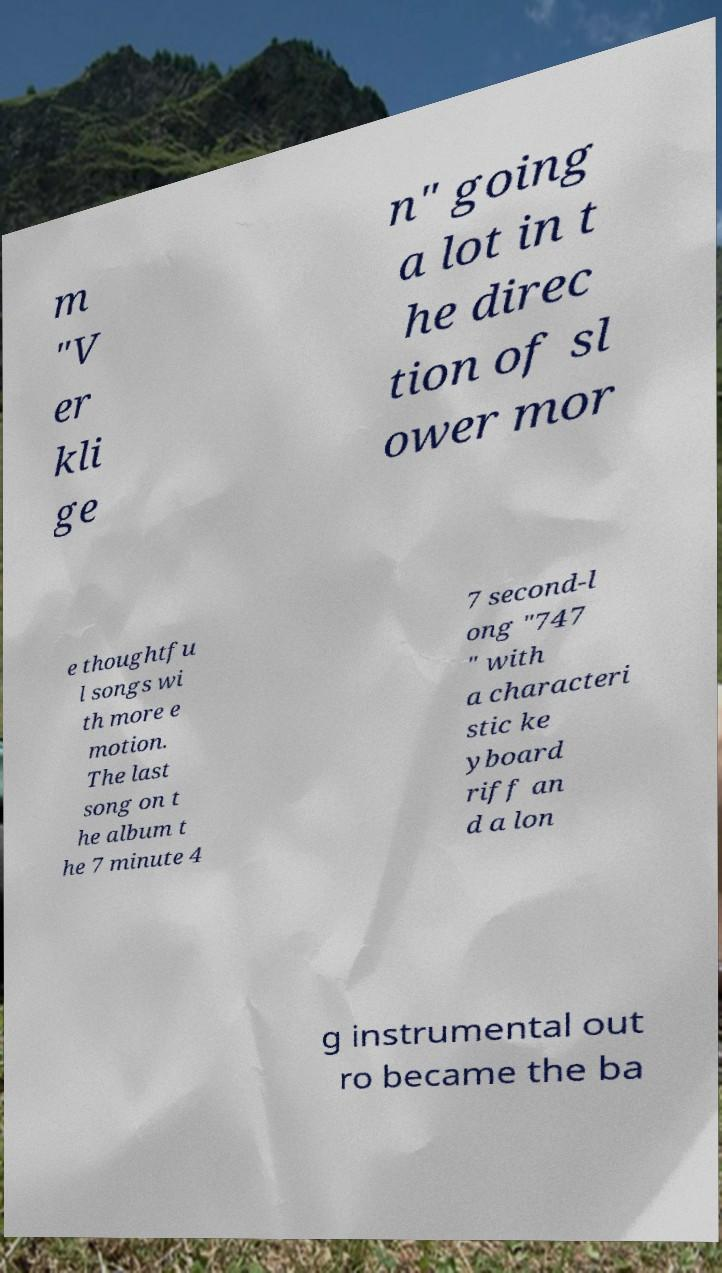What messages or text are displayed in this image? I need them in a readable, typed format. m "V er kli ge n" going a lot in t he direc tion of sl ower mor e thoughtfu l songs wi th more e motion. The last song on t he album t he 7 minute 4 7 second-l ong "747 " with a characteri stic ke yboard riff an d a lon g instrumental out ro became the ba 